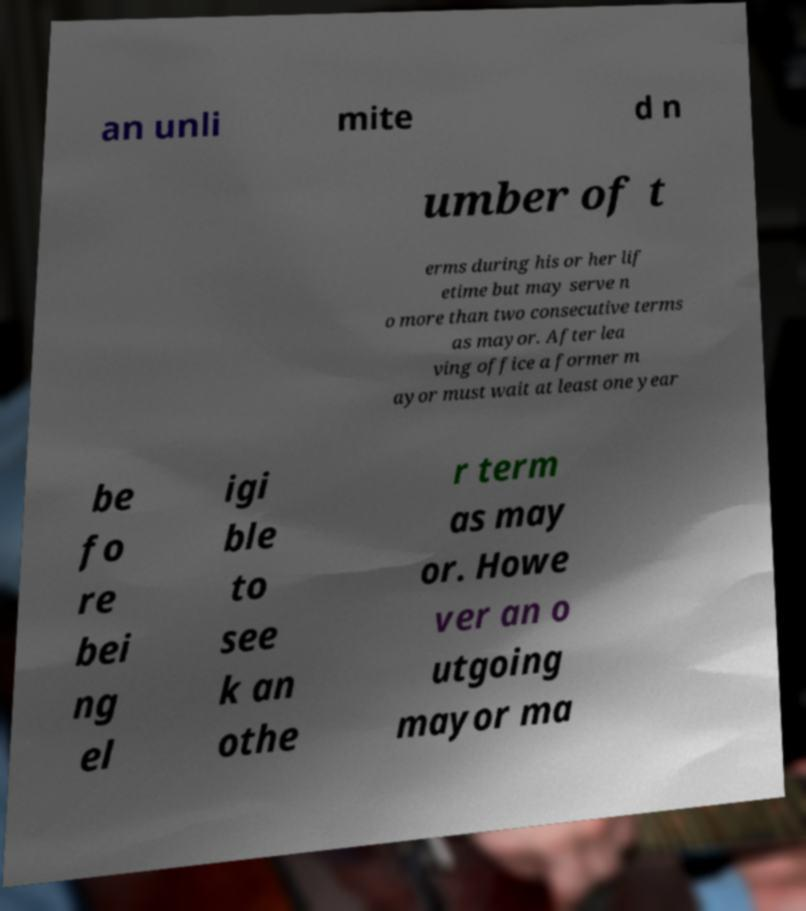I need the written content from this picture converted into text. Can you do that? an unli mite d n umber of t erms during his or her lif etime but may serve n o more than two consecutive terms as mayor. After lea ving office a former m ayor must wait at least one year be fo re bei ng el igi ble to see k an othe r term as may or. Howe ver an o utgoing mayor ma 